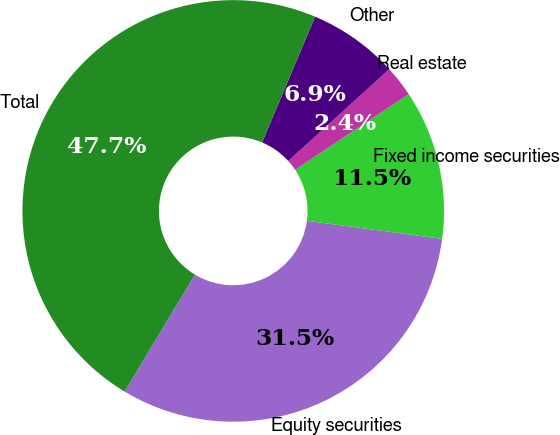Convert chart to OTSL. <chart><loc_0><loc_0><loc_500><loc_500><pie_chart><fcel>Equity securities<fcel>Fixed income securities<fcel>Real estate<fcel>Other<fcel>Total<nl><fcel>31.5%<fcel>11.46%<fcel>2.39%<fcel>6.92%<fcel>47.73%<nl></chart> 